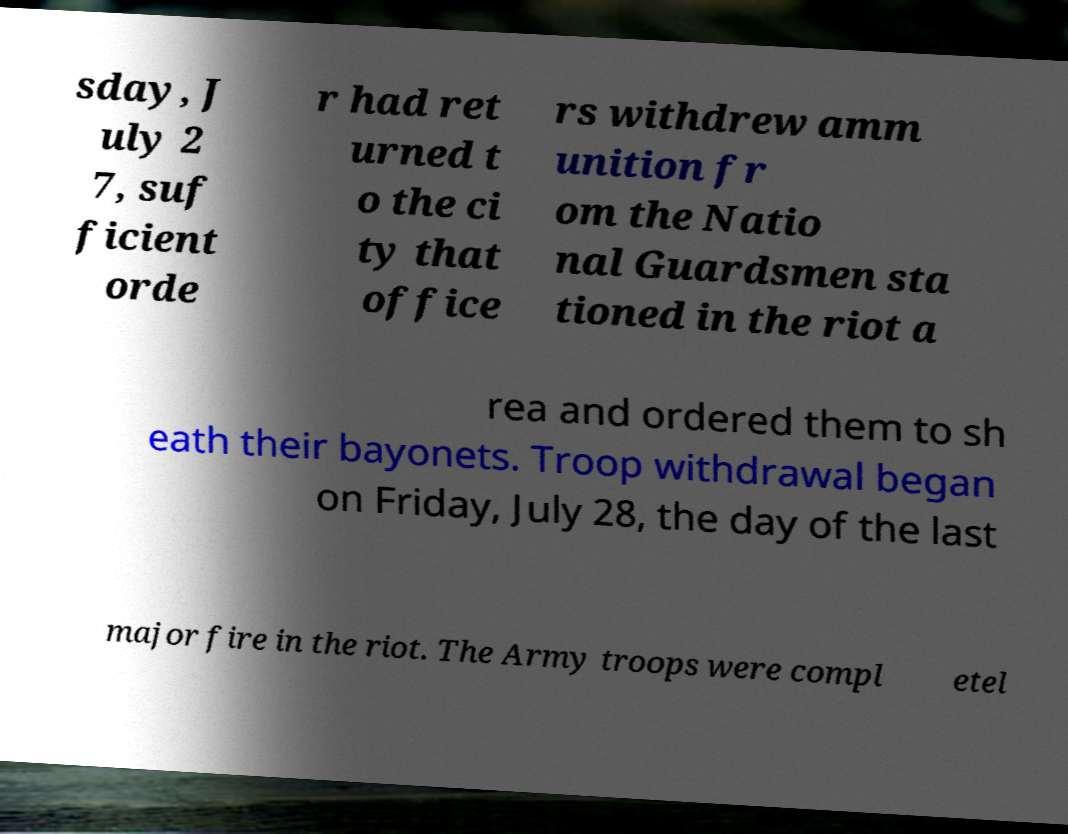Please read and relay the text visible in this image. What does it say? sday, J uly 2 7, suf ficient orde r had ret urned t o the ci ty that office rs withdrew amm unition fr om the Natio nal Guardsmen sta tioned in the riot a rea and ordered them to sh eath their bayonets. Troop withdrawal began on Friday, July 28, the day of the last major fire in the riot. The Army troops were compl etel 